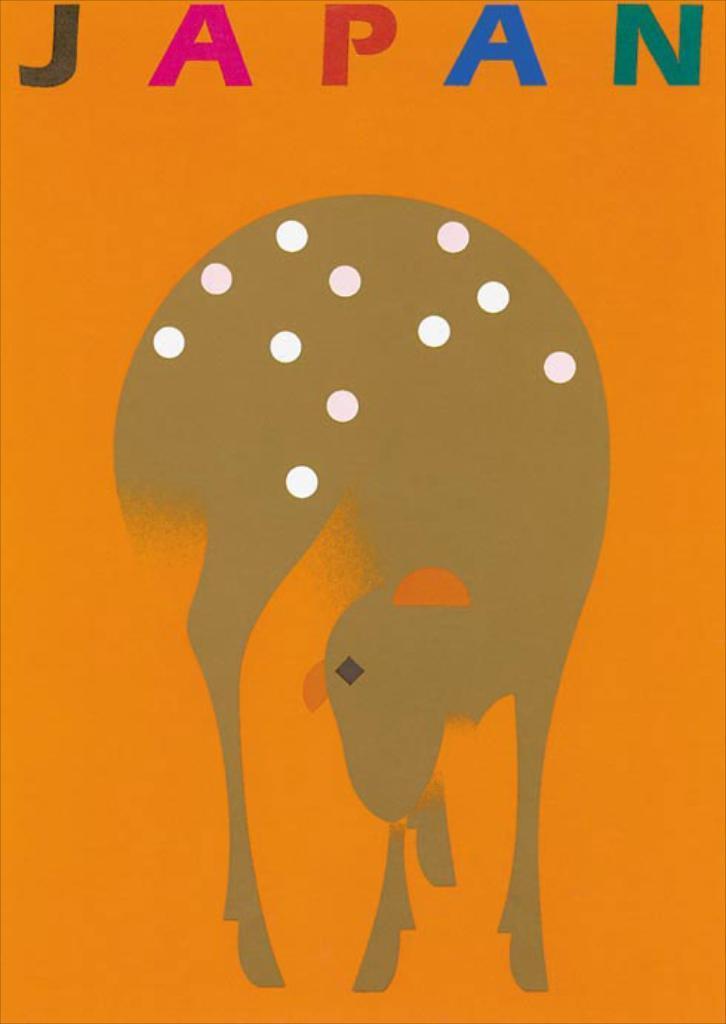In one or two sentences, can you explain what this image depicts? In this image I can see an orange colour thing and on it I can see a drawing. On the top side of this image I can see something is written in different colours and in the centre of the image I can see number of white dots. 